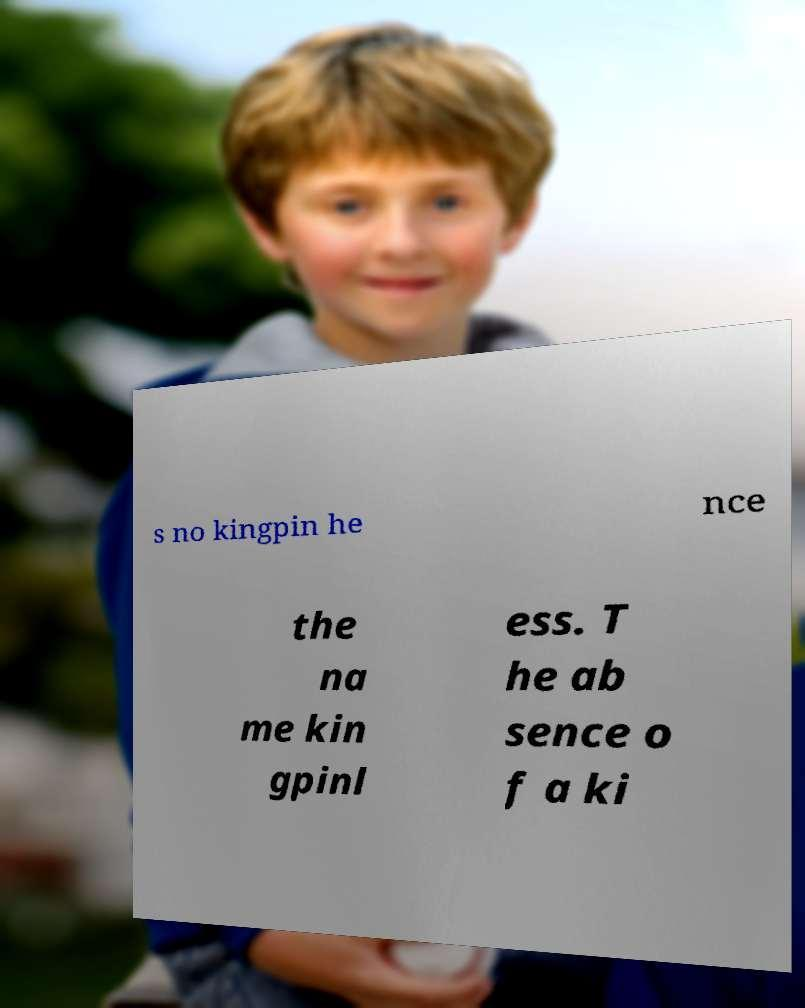For documentation purposes, I need the text within this image transcribed. Could you provide that? s no kingpin he nce the na me kin gpinl ess. T he ab sence o f a ki 